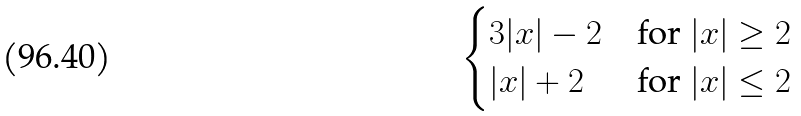<formula> <loc_0><loc_0><loc_500><loc_500>\begin{cases} 3 | x | - 2 & \text {for } | x | \geq 2 \\ | x | + 2 & \text {for } | x | \leq 2 \end{cases}</formula> 